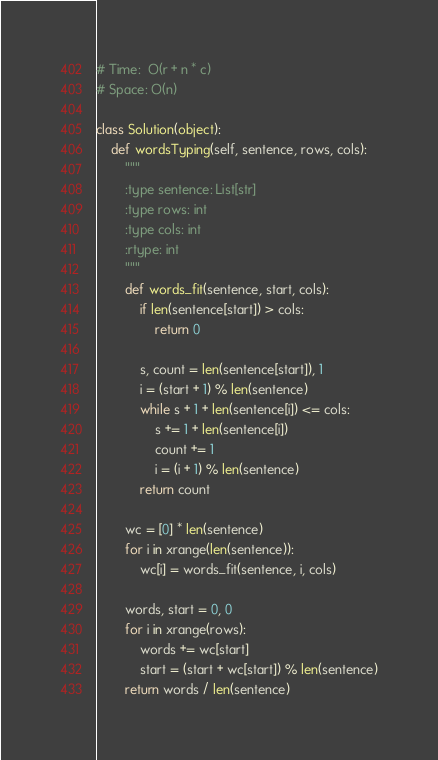<code> <loc_0><loc_0><loc_500><loc_500><_Python_># Time:  O(r + n * c)
# Space: O(n)

class Solution(object):
    def wordsTyping(self, sentence, rows, cols):
        """
        :type sentence: List[str]
        :type rows: int
        :type cols: int
        :rtype: int
        """
        def words_fit(sentence, start, cols):
            if len(sentence[start]) > cols:
                return 0
    
            s, count = len(sentence[start]), 1
            i = (start + 1) % len(sentence)
            while s + 1 + len(sentence[i]) <= cols:
                s += 1 + len(sentence[i])
                count += 1
                i = (i + 1) % len(sentence)
            return count

        wc = [0] * len(sentence)
        for i in xrange(len(sentence)):
            wc[i] = words_fit(sentence, i, cols)

        words, start = 0, 0
        for i in xrange(rows):
            words += wc[start]
            start = (start + wc[start]) % len(sentence)
        return words / len(sentence)
</code> 